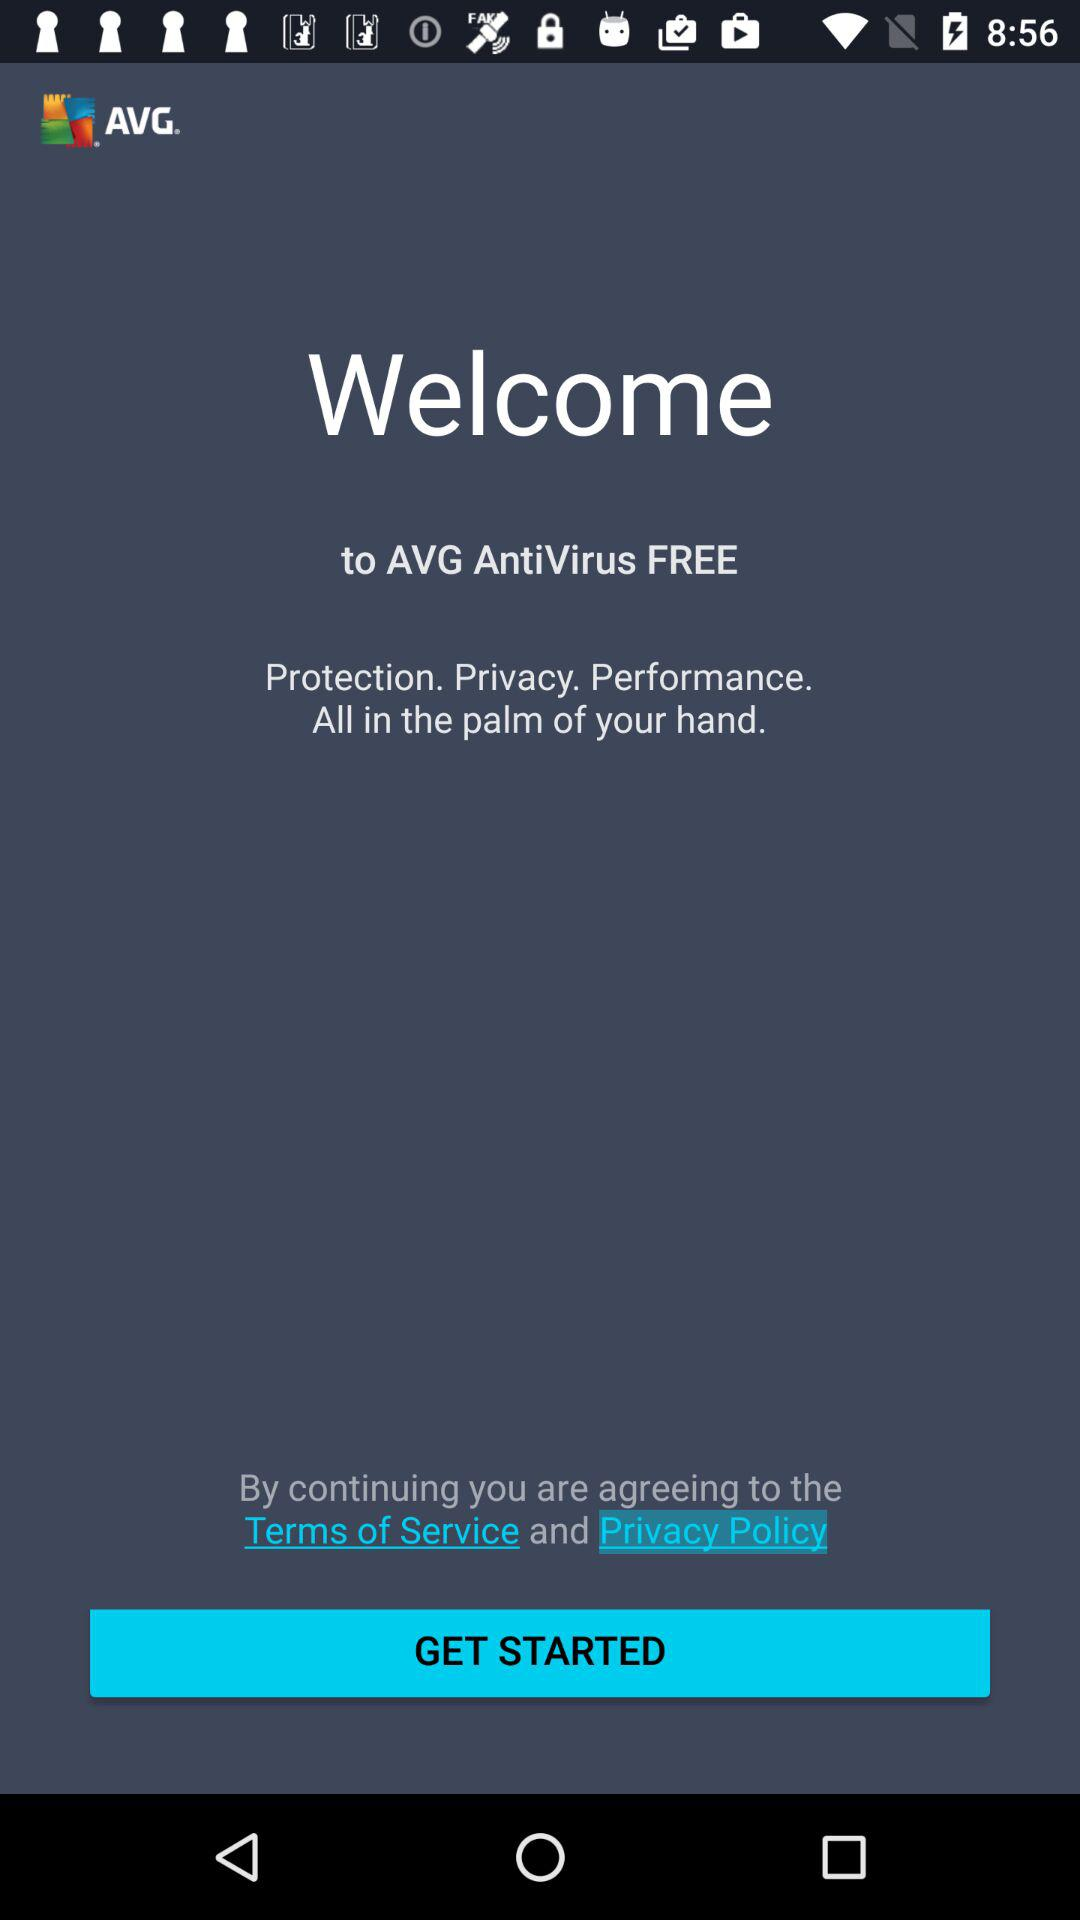What is the name of the application? The name of the application is "AVG AntiVirus FREE". 